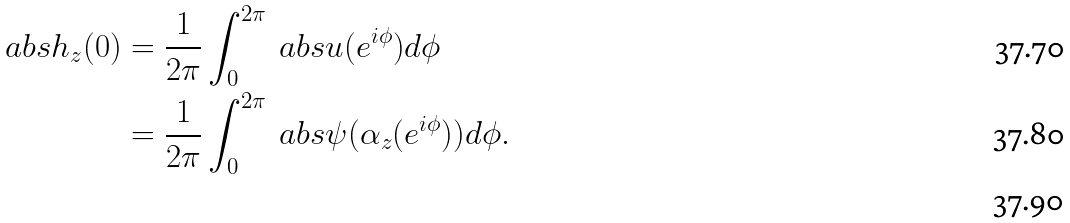Convert formula to latex. <formula><loc_0><loc_0><loc_500><loc_500>\ a b s { h _ { z } ( 0 ) } & = \frac { 1 } { 2 \pi } \int _ { 0 } ^ { 2 \pi } \ a b s { u ( e ^ { i \phi } ) } d \phi \\ & = \frac { 1 } { 2 \pi } \int _ { 0 } ^ { 2 \pi } \ a b s { \psi ( \alpha _ { z } ( e ^ { i \phi } ) ) } d \phi . \\</formula> 